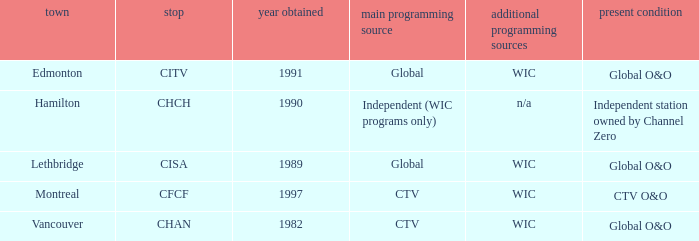Which station is located in edmonton CITV. 